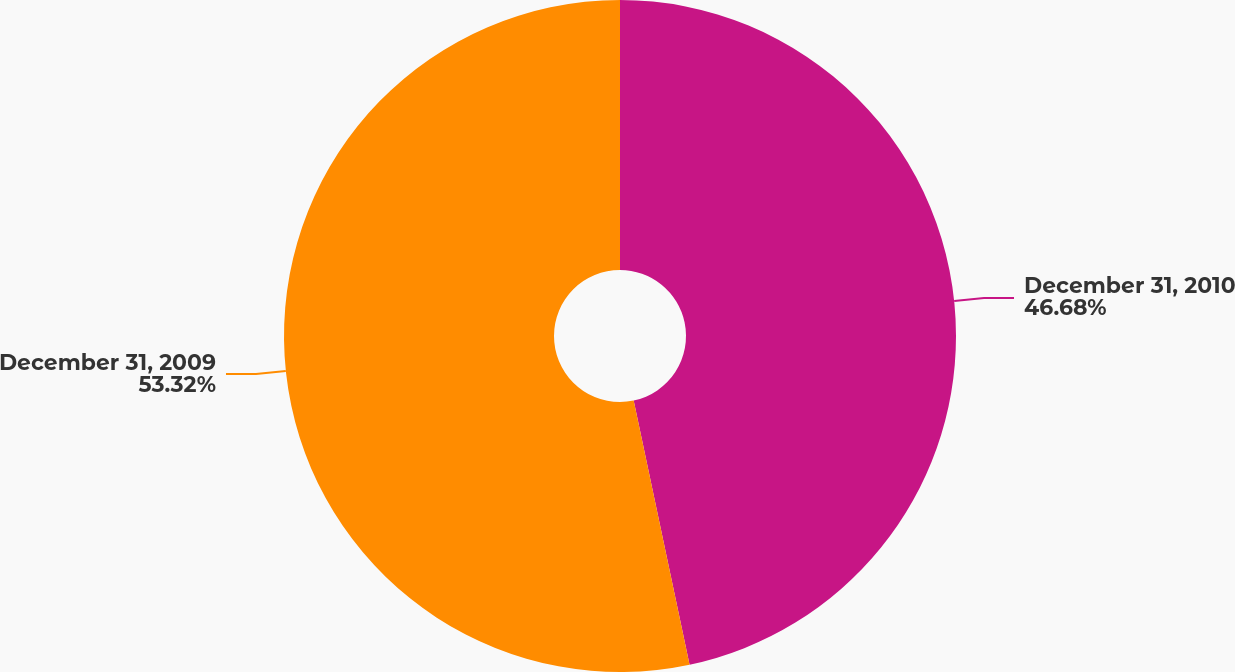Convert chart to OTSL. <chart><loc_0><loc_0><loc_500><loc_500><pie_chart><fcel>December 31, 2010<fcel>December 31, 2009<nl><fcel>46.68%<fcel>53.32%<nl></chart> 